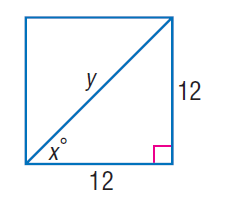Answer the mathemtical geometry problem and directly provide the correct option letter.
Question: Find y.
Choices: A: 6 B: 9 C: 12 D: 12 \sqrt { 2 } D 